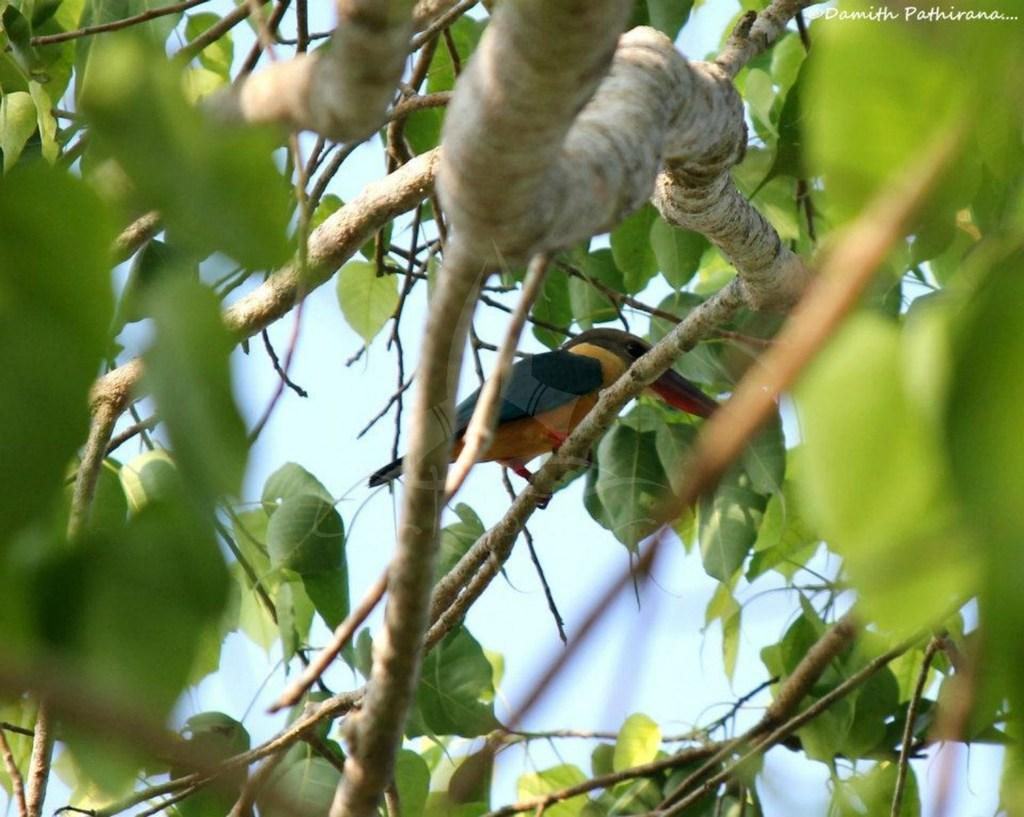What type of animal can be seen in the image? There is a bird in the image. Where is the bird located? The bird is on the branches of a tree. What part of the natural environment is visible in the image? The sky is visible in the image. What type of songs can be heard coming from the bird in the image? There is no indication in the image that the bird is singing or making any sounds, so it cannot be determined from the picture. 